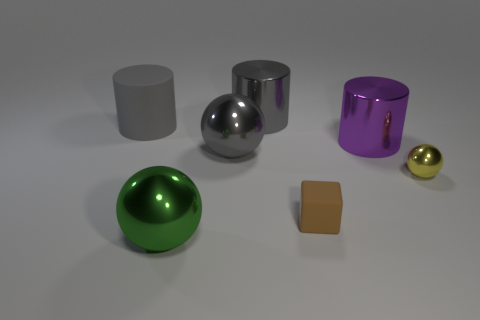What can you infer about the lighting and material of these objects? The lighting in the scene appears to be soft and diffused, with gentle shadows indicating an overhead light source. The materials of the objects vary: the spheres and cylinders have highly reflective surfaces that suggest they are made of polished metals or plastic with a metallic finish. The brown cube, on the other hand, has a matte surface, which indicates it might be made of a non-reflective material like stone or unpolished wood. The small gold sphere has a shiny surface but isn't as reflective as the larger spheres, possibly indicating a different texture or type of material. 